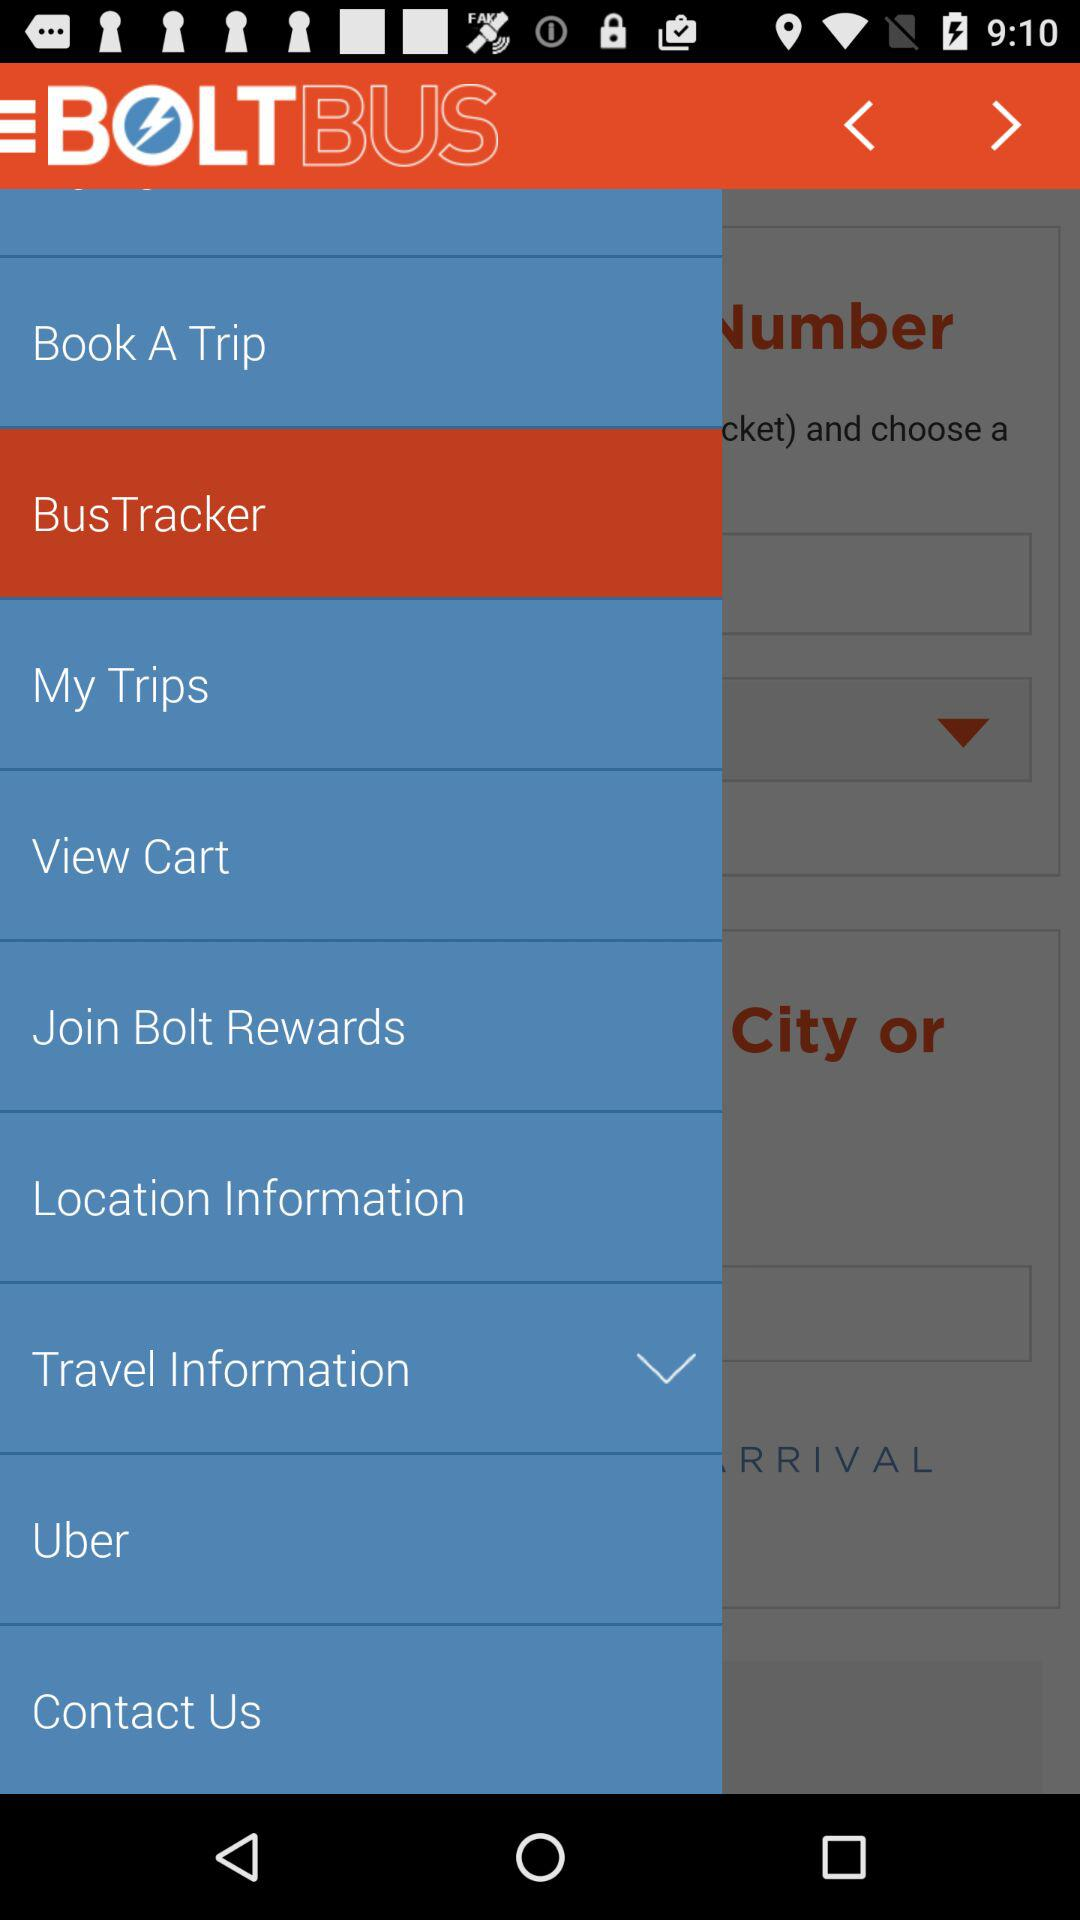What is the selected item in the menu? The selected item is "BusTracker". 